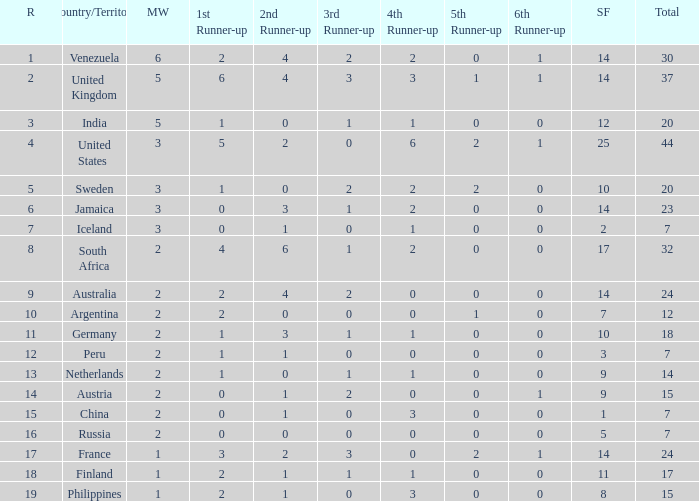What is the united states' standing? 1.0. 